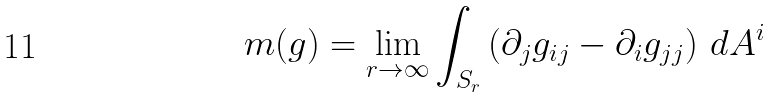<formula> <loc_0><loc_0><loc_500><loc_500>m ( g ) = \lim _ { r \rightarrow \infty } \int _ { S _ { r } } \left ( \partial _ { j } g _ { i j } - \partial _ { i } g _ { j j } \right ) \, d A ^ { i }</formula> 